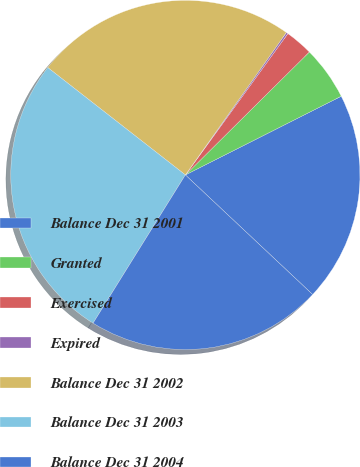Convert chart. <chart><loc_0><loc_0><loc_500><loc_500><pie_chart><fcel>Balance Dec 31 2001<fcel>Granted<fcel>Exercised<fcel>Expired<fcel>Balance Dec 31 2002<fcel>Balance Dec 31 2003<fcel>Balance Dec 31 2004<nl><fcel>19.45%<fcel>4.99%<fcel>2.58%<fcel>0.17%<fcel>24.27%<fcel>26.68%<fcel>21.86%<nl></chart> 